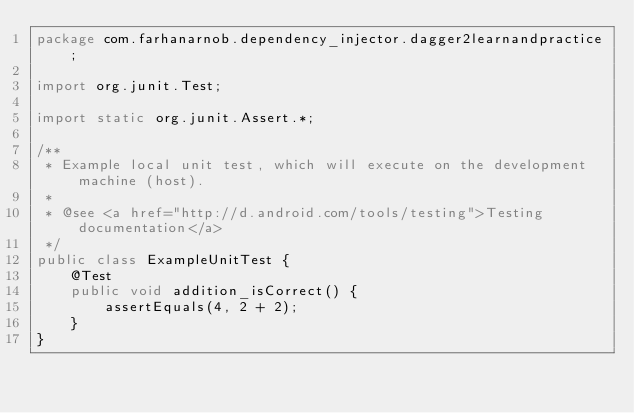<code> <loc_0><loc_0><loc_500><loc_500><_Java_>package com.farhanarnob.dependency_injector.dagger2learnandpractice;

import org.junit.Test;

import static org.junit.Assert.*;

/**
 * Example local unit test, which will execute on the development machine (host).
 *
 * @see <a href="http://d.android.com/tools/testing">Testing documentation</a>
 */
public class ExampleUnitTest {
    @Test
    public void addition_isCorrect() {
        assertEquals(4, 2 + 2);
    }
}</code> 